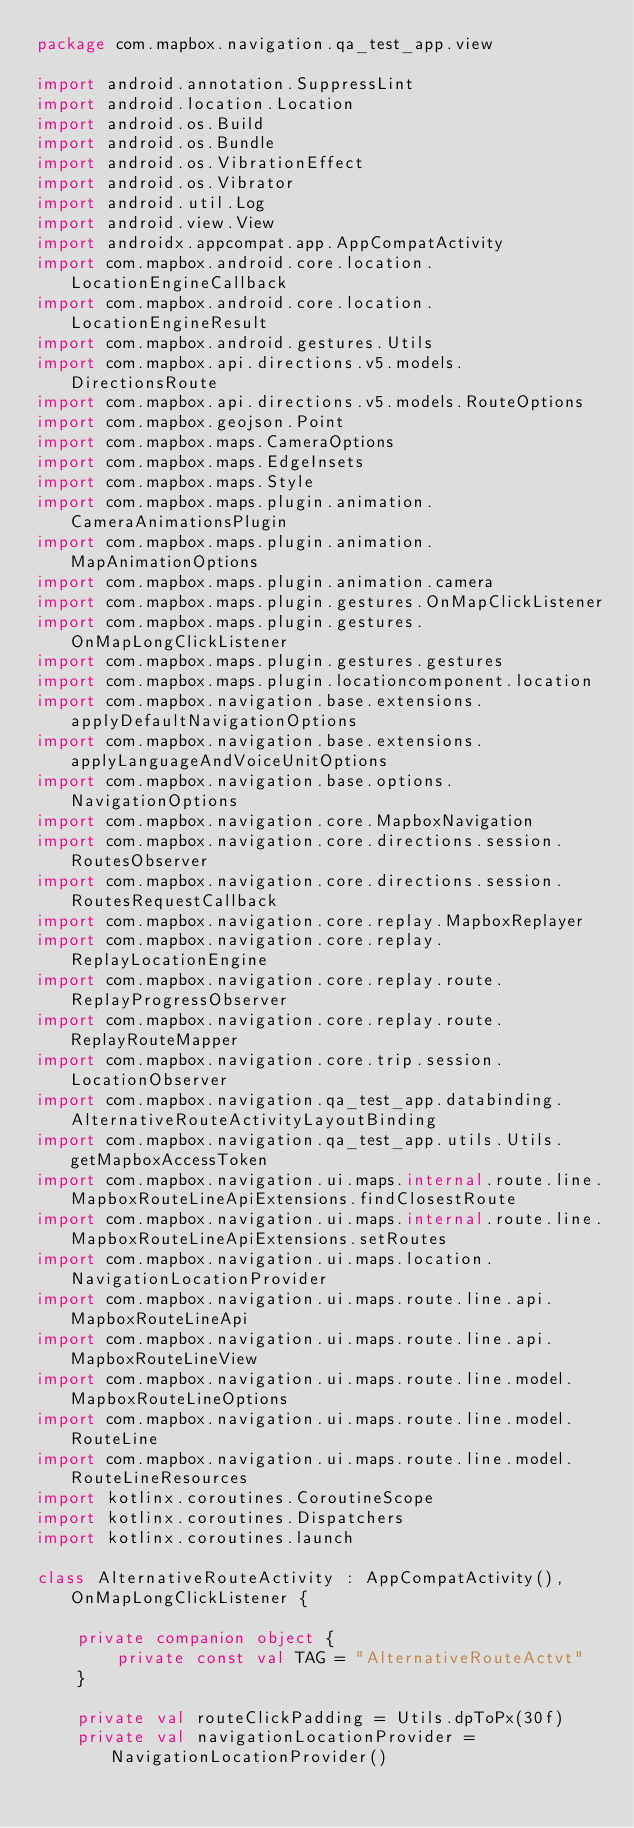<code> <loc_0><loc_0><loc_500><loc_500><_Kotlin_>package com.mapbox.navigation.qa_test_app.view

import android.annotation.SuppressLint
import android.location.Location
import android.os.Build
import android.os.Bundle
import android.os.VibrationEffect
import android.os.Vibrator
import android.util.Log
import android.view.View
import androidx.appcompat.app.AppCompatActivity
import com.mapbox.android.core.location.LocationEngineCallback
import com.mapbox.android.core.location.LocationEngineResult
import com.mapbox.android.gestures.Utils
import com.mapbox.api.directions.v5.models.DirectionsRoute
import com.mapbox.api.directions.v5.models.RouteOptions
import com.mapbox.geojson.Point
import com.mapbox.maps.CameraOptions
import com.mapbox.maps.EdgeInsets
import com.mapbox.maps.Style
import com.mapbox.maps.plugin.animation.CameraAnimationsPlugin
import com.mapbox.maps.plugin.animation.MapAnimationOptions
import com.mapbox.maps.plugin.animation.camera
import com.mapbox.maps.plugin.gestures.OnMapClickListener
import com.mapbox.maps.plugin.gestures.OnMapLongClickListener
import com.mapbox.maps.plugin.gestures.gestures
import com.mapbox.maps.plugin.locationcomponent.location
import com.mapbox.navigation.base.extensions.applyDefaultNavigationOptions
import com.mapbox.navigation.base.extensions.applyLanguageAndVoiceUnitOptions
import com.mapbox.navigation.base.options.NavigationOptions
import com.mapbox.navigation.core.MapboxNavigation
import com.mapbox.navigation.core.directions.session.RoutesObserver
import com.mapbox.navigation.core.directions.session.RoutesRequestCallback
import com.mapbox.navigation.core.replay.MapboxReplayer
import com.mapbox.navigation.core.replay.ReplayLocationEngine
import com.mapbox.navigation.core.replay.route.ReplayProgressObserver
import com.mapbox.navigation.core.replay.route.ReplayRouteMapper
import com.mapbox.navigation.core.trip.session.LocationObserver
import com.mapbox.navigation.qa_test_app.databinding.AlternativeRouteActivityLayoutBinding
import com.mapbox.navigation.qa_test_app.utils.Utils.getMapboxAccessToken
import com.mapbox.navigation.ui.maps.internal.route.line.MapboxRouteLineApiExtensions.findClosestRoute
import com.mapbox.navigation.ui.maps.internal.route.line.MapboxRouteLineApiExtensions.setRoutes
import com.mapbox.navigation.ui.maps.location.NavigationLocationProvider
import com.mapbox.navigation.ui.maps.route.line.api.MapboxRouteLineApi
import com.mapbox.navigation.ui.maps.route.line.api.MapboxRouteLineView
import com.mapbox.navigation.ui.maps.route.line.model.MapboxRouteLineOptions
import com.mapbox.navigation.ui.maps.route.line.model.RouteLine
import com.mapbox.navigation.ui.maps.route.line.model.RouteLineResources
import kotlinx.coroutines.CoroutineScope
import kotlinx.coroutines.Dispatchers
import kotlinx.coroutines.launch

class AlternativeRouteActivity : AppCompatActivity(), OnMapLongClickListener {

    private companion object {
        private const val TAG = "AlternativeRouteActvt"
    }

    private val routeClickPadding = Utils.dpToPx(30f)
    private val navigationLocationProvider = NavigationLocationProvider()</code> 